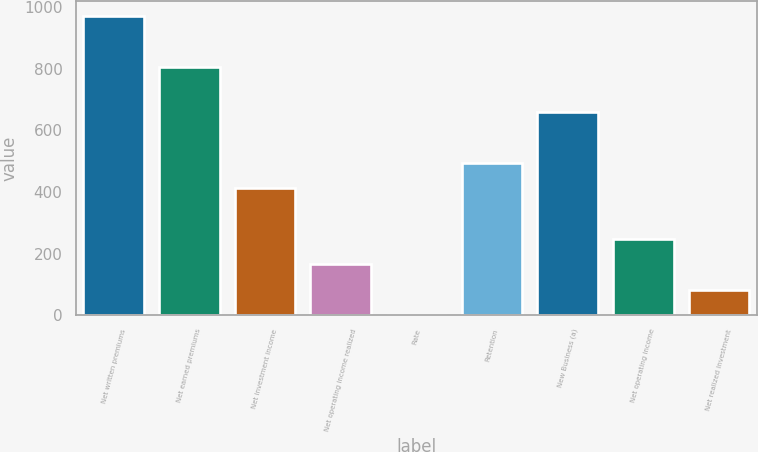<chart> <loc_0><loc_0><loc_500><loc_500><bar_chart><fcel>Net written premiums<fcel>Net earned premiums<fcel>Net investment income<fcel>Net operating income realized<fcel>Rate<fcel>Retention<fcel>New Business (a)<fcel>Net operating income<fcel>Net realized investment<nl><fcel>970.2<fcel>806<fcel>411.5<fcel>165.2<fcel>1<fcel>493.6<fcel>657.8<fcel>247.3<fcel>83.1<nl></chart> 